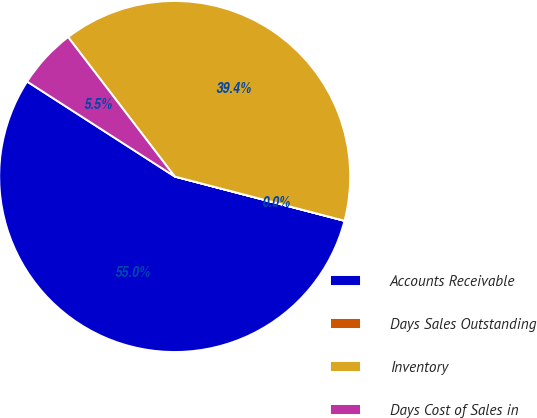<chart> <loc_0><loc_0><loc_500><loc_500><pie_chart><fcel>Accounts Receivable<fcel>Days Sales Outstanding<fcel>Inventory<fcel>Days Cost of Sales in<nl><fcel>55.04%<fcel>0.01%<fcel>39.45%<fcel>5.51%<nl></chart> 